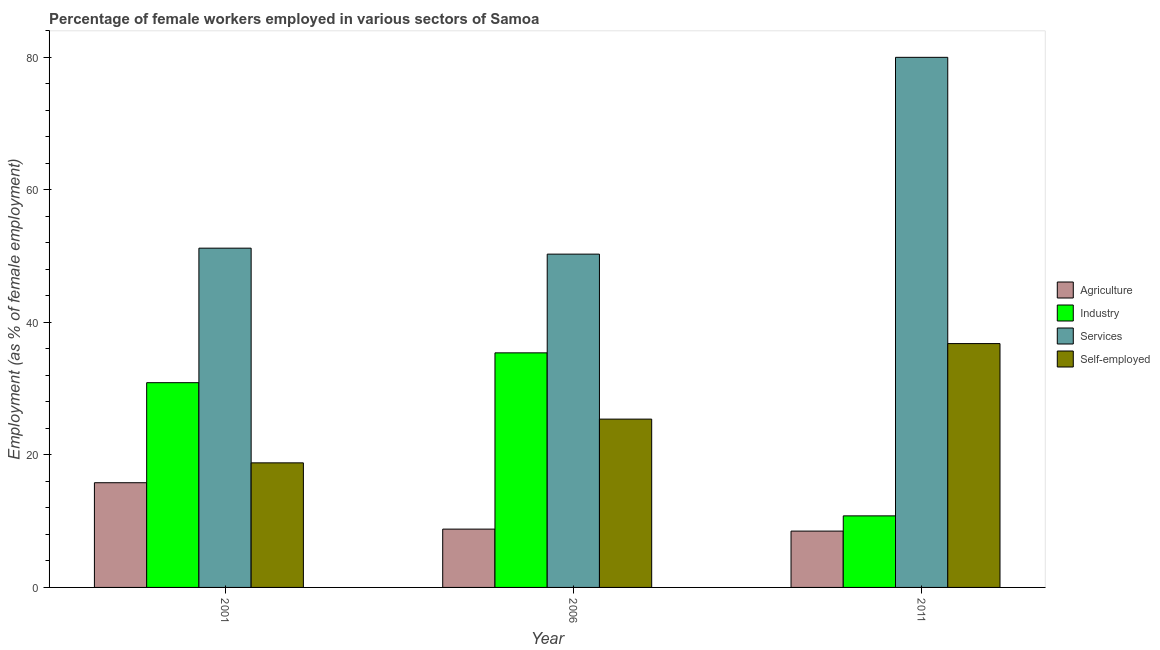How many groups of bars are there?
Keep it short and to the point. 3. Are the number of bars per tick equal to the number of legend labels?
Offer a terse response. Yes. Are the number of bars on each tick of the X-axis equal?
Make the answer very short. Yes. What is the percentage of self employed female workers in 2011?
Your response must be concise. 36.8. Across all years, what is the maximum percentage of self employed female workers?
Provide a short and direct response. 36.8. Across all years, what is the minimum percentage of female workers in services?
Offer a terse response. 50.3. In which year was the percentage of female workers in agriculture maximum?
Offer a very short reply. 2001. What is the total percentage of female workers in services in the graph?
Your response must be concise. 181.5. What is the difference between the percentage of female workers in industry in 2001 and that in 2006?
Your answer should be very brief. -4.5. What is the difference between the percentage of female workers in agriculture in 2011 and the percentage of female workers in services in 2001?
Offer a terse response. -7.3. What is the average percentage of female workers in agriculture per year?
Offer a terse response. 11.03. What is the ratio of the percentage of female workers in agriculture in 2006 to that in 2011?
Keep it short and to the point. 1.04. What is the difference between the highest and the second highest percentage of female workers in agriculture?
Make the answer very short. 7. What is the difference between the highest and the lowest percentage of female workers in industry?
Make the answer very short. 24.6. In how many years, is the percentage of self employed female workers greater than the average percentage of self employed female workers taken over all years?
Your answer should be compact. 1. Is the sum of the percentage of self employed female workers in 2001 and 2011 greater than the maximum percentage of female workers in industry across all years?
Provide a succinct answer. Yes. Is it the case that in every year, the sum of the percentage of self employed female workers and percentage of female workers in agriculture is greater than the sum of percentage of female workers in services and percentage of female workers in industry?
Keep it short and to the point. No. What does the 2nd bar from the left in 2006 represents?
Offer a terse response. Industry. What does the 2nd bar from the right in 2001 represents?
Provide a succinct answer. Services. How many bars are there?
Give a very brief answer. 12. Are all the bars in the graph horizontal?
Make the answer very short. No. How many years are there in the graph?
Ensure brevity in your answer.  3. What is the difference between two consecutive major ticks on the Y-axis?
Your answer should be very brief. 20. Where does the legend appear in the graph?
Your response must be concise. Center right. How many legend labels are there?
Make the answer very short. 4. How are the legend labels stacked?
Offer a terse response. Vertical. What is the title of the graph?
Provide a short and direct response. Percentage of female workers employed in various sectors of Samoa. Does "Compensation of employees" appear as one of the legend labels in the graph?
Provide a succinct answer. No. What is the label or title of the Y-axis?
Make the answer very short. Employment (as % of female employment). What is the Employment (as % of female employment) in Agriculture in 2001?
Your response must be concise. 15.8. What is the Employment (as % of female employment) of Industry in 2001?
Your answer should be very brief. 30.9. What is the Employment (as % of female employment) of Services in 2001?
Provide a short and direct response. 51.2. What is the Employment (as % of female employment) of Self-employed in 2001?
Your response must be concise. 18.8. What is the Employment (as % of female employment) of Agriculture in 2006?
Your answer should be compact. 8.8. What is the Employment (as % of female employment) in Industry in 2006?
Keep it short and to the point. 35.4. What is the Employment (as % of female employment) in Services in 2006?
Provide a succinct answer. 50.3. What is the Employment (as % of female employment) in Self-employed in 2006?
Offer a terse response. 25.4. What is the Employment (as % of female employment) in Agriculture in 2011?
Make the answer very short. 8.5. What is the Employment (as % of female employment) of Industry in 2011?
Ensure brevity in your answer.  10.8. What is the Employment (as % of female employment) of Services in 2011?
Provide a short and direct response. 80. What is the Employment (as % of female employment) of Self-employed in 2011?
Offer a very short reply. 36.8. Across all years, what is the maximum Employment (as % of female employment) of Agriculture?
Your response must be concise. 15.8. Across all years, what is the maximum Employment (as % of female employment) of Industry?
Your answer should be very brief. 35.4. Across all years, what is the maximum Employment (as % of female employment) of Self-employed?
Provide a short and direct response. 36.8. Across all years, what is the minimum Employment (as % of female employment) in Industry?
Provide a succinct answer. 10.8. Across all years, what is the minimum Employment (as % of female employment) of Services?
Keep it short and to the point. 50.3. Across all years, what is the minimum Employment (as % of female employment) of Self-employed?
Offer a terse response. 18.8. What is the total Employment (as % of female employment) of Agriculture in the graph?
Your response must be concise. 33.1. What is the total Employment (as % of female employment) in Industry in the graph?
Offer a very short reply. 77.1. What is the total Employment (as % of female employment) in Services in the graph?
Your answer should be very brief. 181.5. What is the difference between the Employment (as % of female employment) in Agriculture in 2001 and that in 2006?
Your response must be concise. 7. What is the difference between the Employment (as % of female employment) of Industry in 2001 and that in 2006?
Keep it short and to the point. -4.5. What is the difference between the Employment (as % of female employment) in Industry in 2001 and that in 2011?
Ensure brevity in your answer.  20.1. What is the difference between the Employment (as % of female employment) in Services in 2001 and that in 2011?
Provide a succinct answer. -28.8. What is the difference between the Employment (as % of female employment) of Self-employed in 2001 and that in 2011?
Provide a short and direct response. -18. What is the difference between the Employment (as % of female employment) in Industry in 2006 and that in 2011?
Offer a terse response. 24.6. What is the difference between the Employment (as % of female employment) of Services in 2006 and that in 2011?
Offer a terse response. -29.7. What is the difference between the Employment (as % of female employment) of Agriculture in 2001 and the Employment (as % of female employment) of Industry in 2006?
Your response must be concise. -19.6. What is the difference between the Employment (as % of female employment) of Agriculture in 2001 and the Employment (as % of female employment) of Services in 2006?
Offer a terse response. -34.5. What is the difference between the Employment (as % of female employment) in Industry in 2001 and the Employment (as % of female employment) in Services in 2006?
Your answer should be compact. -19.4. What is the difference between the Employment (as % of female employment) of Industry in 2001 and the Employment (as % of female employment) of Self-employed in 2006?
Your answer should be compact. 5.5. What is the difference between the Employment (as % of female employment) in Services in 2001 and the Employment (as % of female employment) in Self-employed in 2006?
Make the answer very short. 25.8. What is the difference between the Employment (as % of female employment) in Agriculture in 2001 and the Employment (as % of female employment) in Services in 2011?
Provide a succinct answer. -64.2. What is the difference between the Employment (as % of female employment) of Agriculture in 2001 and the Employment (as % of female employment) of Self-employed in 2011?
Offer a very short reply. -21. What is the difference between the Employment (as % of female employment) of Industry in 2001 and the Employment (as % of female employment) of Services in 2011?
Provide a short and direct response. -49.1. What is the difference between the Employment (as % of female employment) of Industry in 2001 and the Employment (as % of female employment) of Self-employed in 2011?
Give a very brief answer. -5.9. What is the difference between the Employment (as % of female employment) of Agriculture in 2006 and the Employment (as % of female employment) of Services in 2011?
Keep it short and to the point. -71.2. What is the difference between the Employment (as % of female employment) in Agriculture in 2006 and the Employment (as % of female employment) in Self-employed in 2011?
Offer a terse response. -28. What is the difference between the Employment (as % of female employment) of Industry in 2006 and the Employment (as % of female employment) of Services in 2011?
Offer a very short reply. -44.6. What is the average Employment (as % of female employment) in Agriculture per year?
Ensure brevity in your answer.  11.03. What is the average Employment (as % of female employment) in Industry per year?
Your response must be concise. 25.7. What is the average Employment (as % of female employment) in Services per year?
Keep it short and to the point. 60.5. What is the average Employment (as % of female employment) of Self-employed per year?
Provide a short and direct response. 27. In the year 2001, what is the difference between the Employment (as % of female employment) in Agriculture and Employment (as % of female employment) in Industry?
Your response must be concise. -15.1. In the year 2001, what is the difference between the Employment (as % of female employment) of Agriculture and Employment (as % of female employment) of Services?
Provide a succinct answer. -35.4. In the year 2001, what is the difference between the Employment (as % of female employment) in Industry and Employment (as % of female employment) in Services?
Provide a succinct answer. -20.3. In the year 2001, what is the difference between the Employment (as % of female employment) of Industry and Employment (as % of female employment) of Self-employed?
Your answer should be very brief. 12.1. In the year 2001, what is the difference between the Employment (as % of female employment) in Services and Employment (as % of female employment) in Self-employed?
Your answer should be very brief. 32.4. In the year 2006, what is the difference between the Employment (as % of female employment) of Agriculture and Employment (as % of female employment) of Industry?
Your response must be concise. -26.6. In the year 2006, what is the difference between the Employment (as % of female employment) of Agriculture and Employment (as % of female employment) of Services?
Your response must be concise. -41.5. In the year 2006, what is the difference between the Employment (as % of female employment) in Agriculture and Employment (as % of female employment) in Self-employed?
Provide a succinct answer. -16.6. In the year 2006, what is the difference between the Employment (as % of female employment) of Industry and Employment (as % of female employment) of Services?
Make the answer very short. -14.9. In the year 2006, what is the difference between the Employment (as % of female employment) of Industry and Employment (as % of female employment) of Self-employed?
Provide a succinct answer. 10. In the year 2006, what is the difference between the Employment (as % of female employment) in Services and Employment (as % of female employment) in Self-employed?
Your answer should be very brief. 24.9. In the year 2011, what is the difference between the Employment (as % of female employment) in Agriculture and Employment (as % of female employment) in Services?
Offer a terse response. -71.5. In the year 2011, what is the difference between the Employment (as % of female employment) in Agriculture and Employment (as % of female employment) in Self-employed?
Your response must be concise. -28.3. In the year 2011, what is the difference between the Employment (as % of female employment) of Industry and Employment (as % of female employment) of Services?
Offer a terse response. -69.2. In the year 2011, what is the difference between the Employment (as % of female employment) of Services and Employment (as % of female employment) of Self-employed?
Provide a succinct answer. 43.2. What is the ratio of the Employment (as % of female employment) in Agriculture in 2001 to that in 2006?
Offer a very short reply. 1.8. What is the ratio of the Employment (as % of female employment) in Industry in 2001 to that in 2006?
Provide a succinct answer. 0.87. What is the ratio of the Employment (as % of female employment) in Services in 2001 to that in 2006?
Your answer should be very brief. 1.02. What is the ratio of the Employment (as % of female employment) of Self-employed in 2001 to that in 2006?
Provide a succinct answer. 0.74. What is the ratio of the Employment (as % of female employment) of Agriculture in 2001 to that in 2011?
Ensure brevity in your answer.  1.86. What is the ratio of the Employment (as % of female employment) in Industry in 2001 to that in 2011?
Make the answer very short. 2.86. What is the ratio of the Employment (as % of female employment) in Services in 2001 to that in 2011?
Your answer should be compact. 0.64. What is the ratio of the Employment (as % of female employment) of Self-employed in 2001 to that in 2011?
Provide a short and direct response. 0.51. What is the ratio of the Employment (as % of female employment) of Agriculture in 2006 to that in 2011?
Provide a short and direct response. 1.04. What is the ratio of the Employment (as % of female employment) of Industry in 2006 to that in 2011?
Offer a very short reply. 3.28. What is the ratio of the Employment (as % of female employment) in Services in 2006 to that in 2011?
Keep it short and to the point. 0.63. What is the ratio of the Employment (as % of female employment) in Self-employed in 2006 to that in 2011?
Keep it short and to the point. 0.69. What is the difference between the highest and the second highest Employment (as % of female employment) of Agriculture?
Keep it short and to the point. 7. What is the difference between the highest and the second highest Employment (as % of female employment) of Industry?
Your response must be concise. 4.5. What is the difference between the highest and the second highest Employment (as % of female employment) in Services?
Your response must be concise. 28.8. What is the difference between the highest and the lowest Employment (as % of female employment) of Industry?
Offer a terse response. 24.6. What is the difference between the highest and the lowest Employment (as % of female employment) in Services?
Provide a short and direct response. 29.7. 